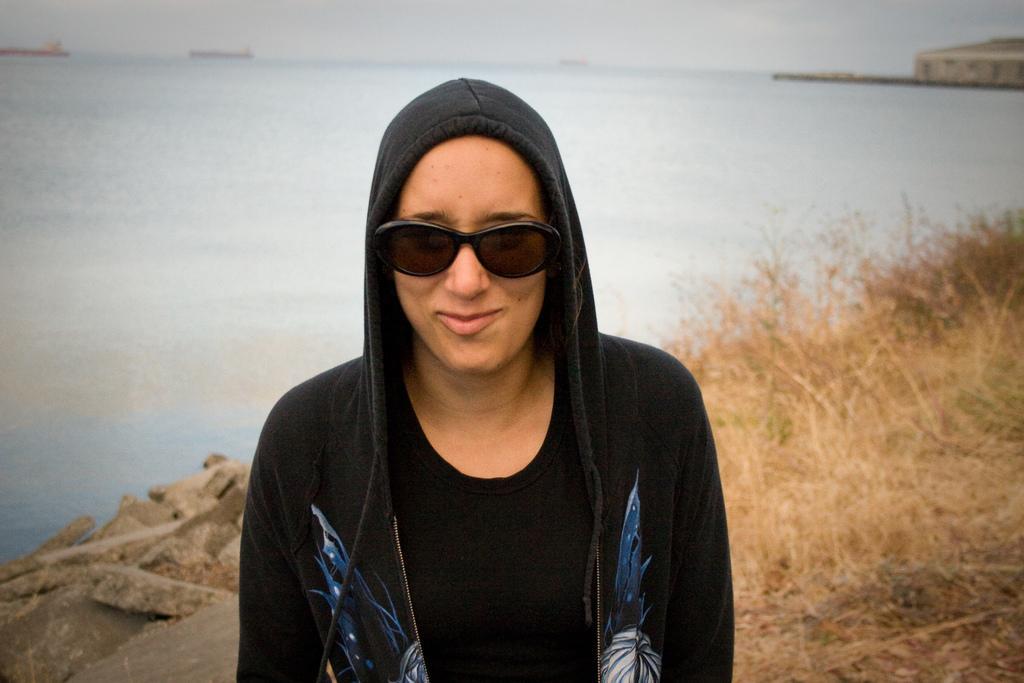In one or two sentences, can you explain what this image depicts? In the middle of the picture I can see one girl standing and looking at the front side. On the right side of the image I can see the grass. In the background, I can see water surface. 